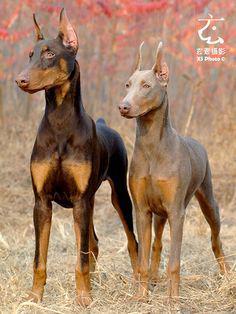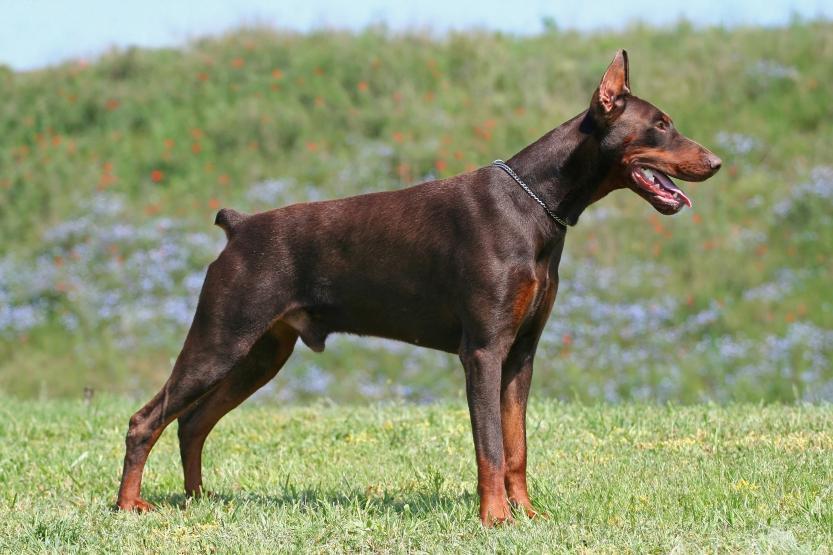The first image is the image on the left, the second image is the image on the right. Analyze the images presented: Is the assertion "A dog is laying down." valid? Answer yes or no. No. The first image is the image on the left, the second image is the image on the right. Considering the images on both sides, is "There are only 2 dogs." valid? Answer yes or no. No. 